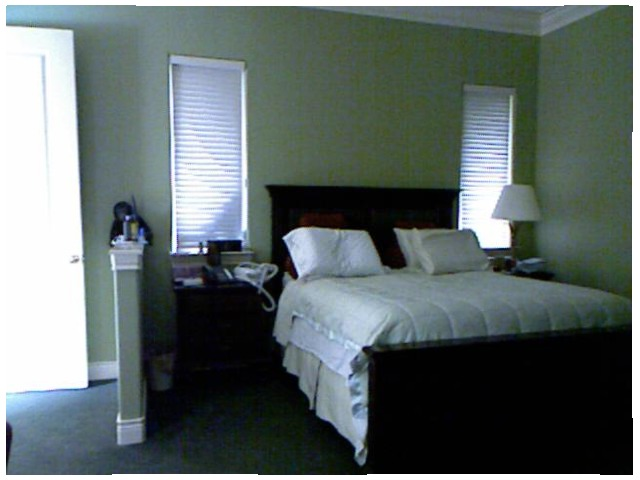<image>
Is there a pillow on the bed? Yes. Looking at the image, I can see the pillow is positioned on top of the bed, with the bed providing support. 